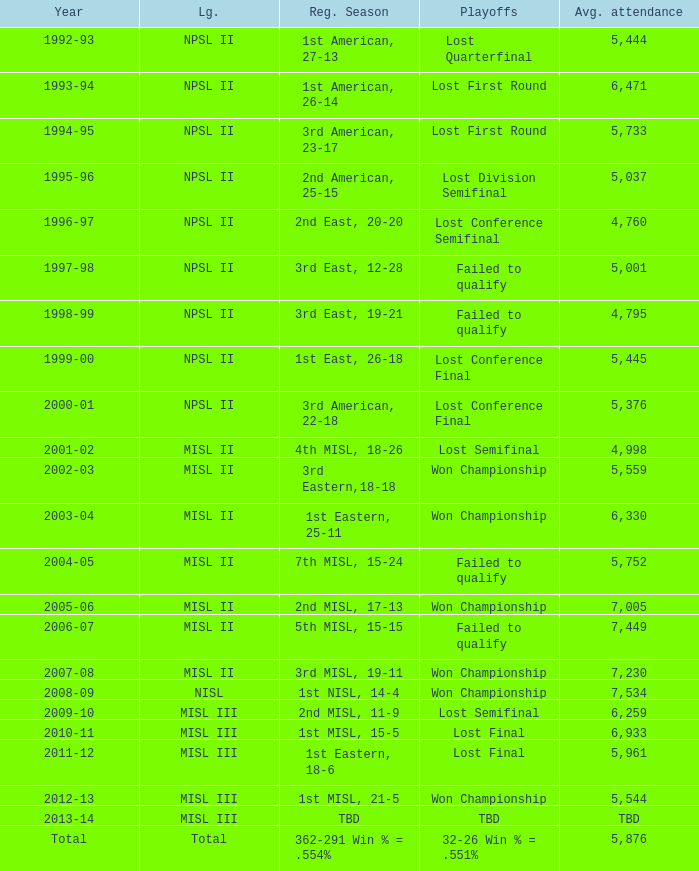When was the year that had an average attendance of 5,445? 1999-00. 